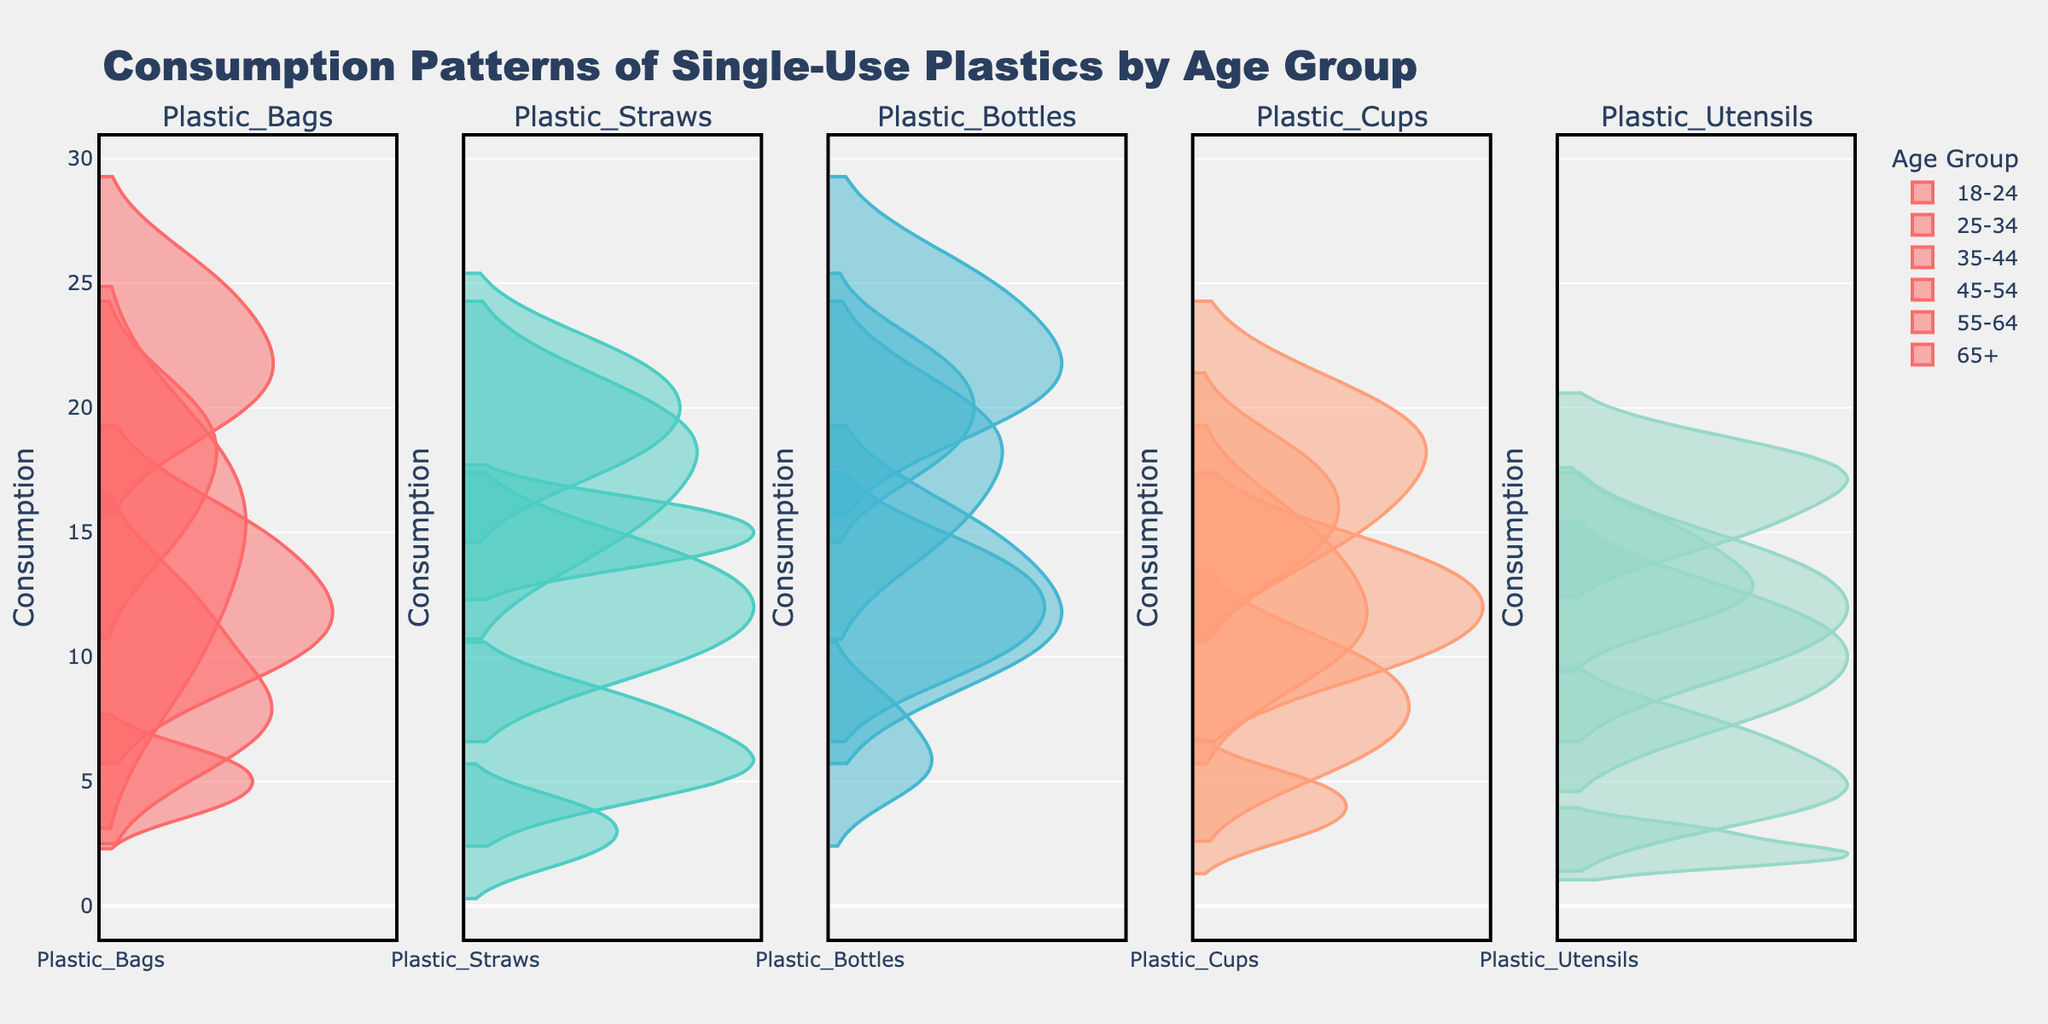what is the main title of the figure? The title of the figure is typically found at the top and provides the viewer with a brief description of what the figure represents. In this case, it indicates the topic, which is "Consumption Patterns of Single-Use Plastics by Age Group."
Answer: Consumption Patterns of Single-Use Plastics by Age Group Which plastic type appears to have the highest consumption among the 18-24 age group? By inspecting all the density plots for the 18-24 age group across different plastic types, we identify the peak density values for each plastic type and compare them. The 18-24 age group shows the highest consumption for Plastic Bottles.
Answer: Plastic Bottles How does the consumption of plastic utensils compare between the 35-44 and 55-64 age groups? To compare, we look at the density plots for plastic utensils for the 35-44 and 55-64 age groups. We observe that the 35-44 age group shows a higher peak density value compared to the 55-64 age group, indicating higher overall consumption.
Answer: Higher for 35-44 What is the overall consumption trend of plastic cups across different age groups? Observing the density plots for plastic cups, we see a decrease in peak density values as age increases. This suggests a downward trend in single-use plastic cup consumption with increasing age.
Answer: Decreasing with age Which plastic type shows the least consumption in the 65+ age group? By examining the density plots for each plastic type in the 65+ age group, we note the plastic type with the lowest peak density value. The 65+ age group has the least consumption for Plastic Utensils.
Answer: Plastic Utensils What age group shows the widest distribution of consumption for plastic straws? Distribution width can be assessed by the spread of the density plot for plastic straws across different age groups. The 18-24 age group shows the widest distribution, indicating more variability in consumption.
Answer: 18-24 Among the 25-34 age group, which plastic type has similar consumption levels with the 45-54 age group? To find a similar consumption level, we compare the density plots of plastic types between the 25-34 and 45-54 age groups. Both age groups show similar density plots for plastic cups.
Answer: Plastic Cups Across all age groups, which plastic type demonstrates the most consistent consumption pattern? Consistency is shown by similar density plots across different age groups. Comparing all density plots, plastic straws exhibit similar patterns, indicating a relatively consistent consumption.
Answer: Plastic Straws What is the approximate range of plastic bags consumption in the 35-44 age group? To find the range, we note the minimum and maximum values in the density plot for plastic bags in the 35-44 age group. The approximate range is from 20 to 25.
Answer: 20-25 Which age group has the lowest average consumption of plastic bottles? By observing the peak densities and spread in the density plots of plastic bottles across age groups, the 65+ age group shows the lowest average consumption due to the lowest peak density and distribution.
Answer: 65+ 